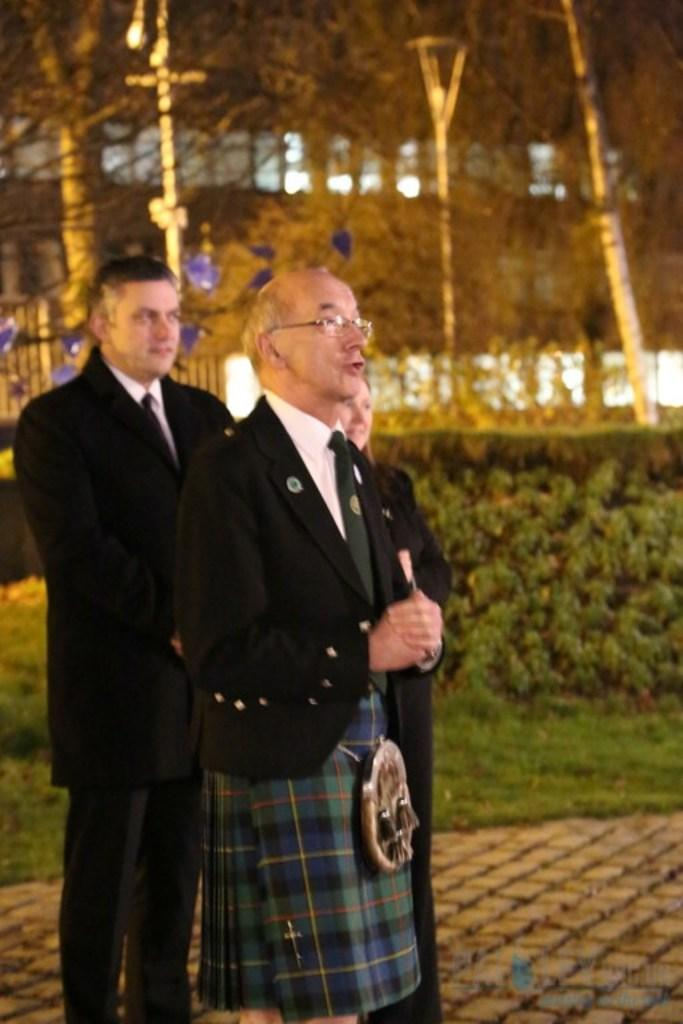How many people are present in the image? There are three persons standing in the image. What can be seen in the background of the image? There is grass, plants, trees, and a building in the background of the image. What type of drink is the monkey holding in the image? There is no monkey present in the image, so it is not possible to determine what type of drink it might be holding. 